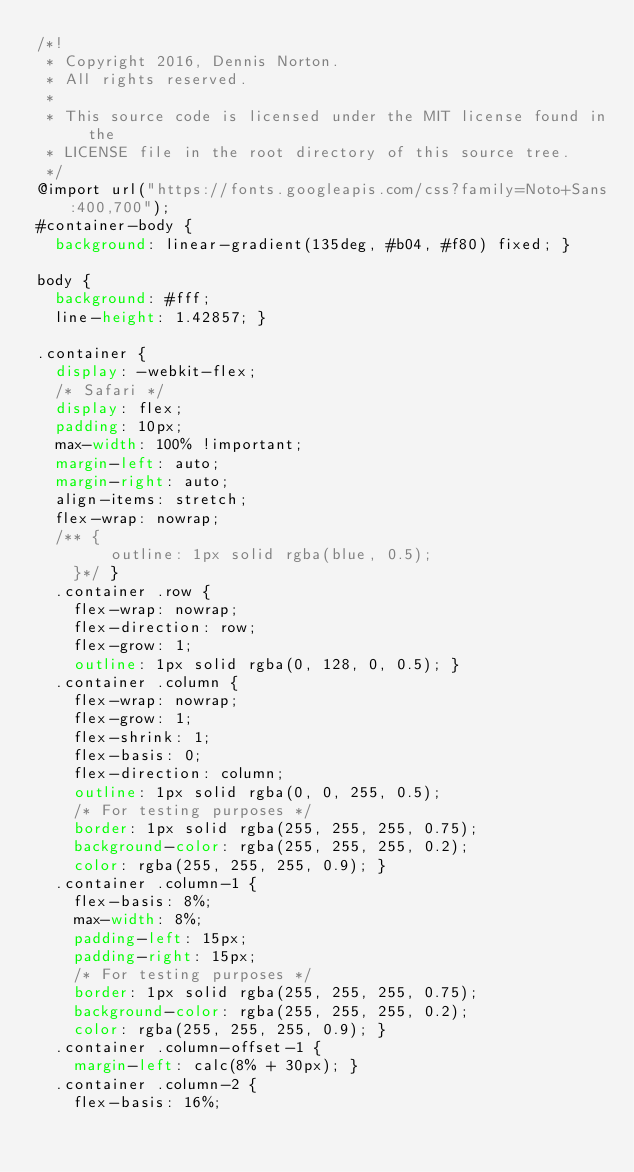Convert code to text. <code><loc_0><loc_0><loc_500><loc_500><_CSS_>/*!
 * Copyright 2016, Dennis Norton.
 * All rights reserved.
 *
 * This source code is licensed under the MIT license found in the
 * LICENSE file in the root directory of this source tree.
 */
@import url("https://fonts.googleapis.com/css?family=Noto+Sans:400,700");
#container-body {
  background: linear-gradient(135deg, #b04, #f80) fixed; }

body {
  background: #fff;
  line-height: 1.42857; }

.container {
  display: -webkit-flex;
  /* Safari */
  display: flex;
  padding: 10px;
  max-width: 100% !important;
  margin-left: auto;
  margin-right: auto;
  align-items: stretch;
  flex-wrap: nowrap;
  /** {
        outline: 1px solid rgba(blue, 0.5); 
    }*/ }
  .container .row {
    flex-wrap: nowrap;
    flex-direction: row;
    flex-grow: 1;
    outline: 1px solid rgba(0, 128, 0, 0.5); }
  .container .column {
    flex-wrap: nowrap;
    flex-grow: 1;
    flex-shrink: 1;
    flex-basis: 0;
    flex-direction: column;
    outline: 1px solid rgba(0, 0, 255, 0.5);
    /* For testing purposes */
    border: 1px solid rgba(255, 255, 255, 0.75);
    background-color: rgba(255, 255, 255, 0.2);
    color: rgba(255, 255, 255, 0.9); }
  .container .column-1 {
    flex-basis: 8%;
    max-width: 8%;
    padding-left: 15px;
    padding-right: 15px;
    /* For testing purposes */
    border: 1px solid rgba(255, 255, 255, 0.75);
    background-color: rgba(255, 255, 255, 0.2);
    color: rgba(255, 255, 255, 0.9); }
  .container .column-offset-1 {
    margin-left: calc(8% + 30px); }
  .container .column-2 {
    flex-basis: 16%;</code> 